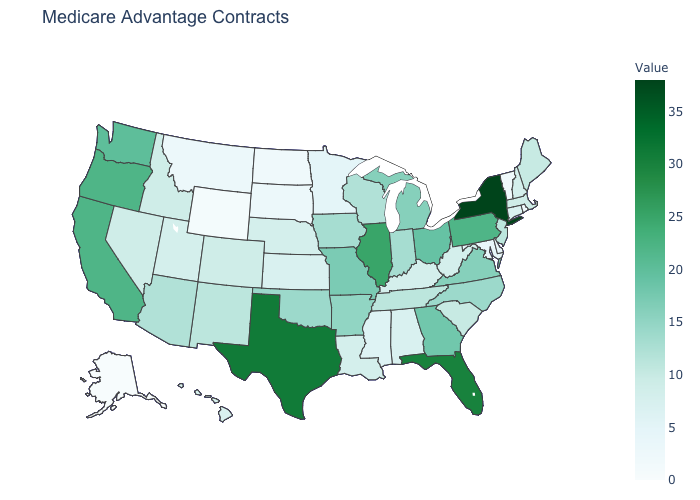Is the legend a continuous bar?
Be succinct. Yes. Which states have the lowest value in the USA?
Write a very short answer. Alaska. Does Alabama have the lowest value in the South?
Give a very brief answer. No. Does New York have the highest value in the USA?
Concise answer only. Yes. Does Minnesota have the highest value in the USA?
Quick response, please. No. 